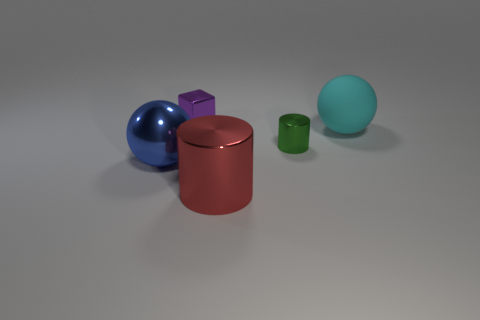Add 1 purple matte balls. How many objects exist? 6 Subtract all cylinders. How many objects are left? 3 Add 1 red metal things. How many red metal things exist? 2 Subtract 1 green cylinders. How many objects are left? 4 Subtract all large brown rubber cubes. Subtract all small shiny cubes. How many objects are left? 4 Add 5 green cylinders. How many green cylinders are left? 6 